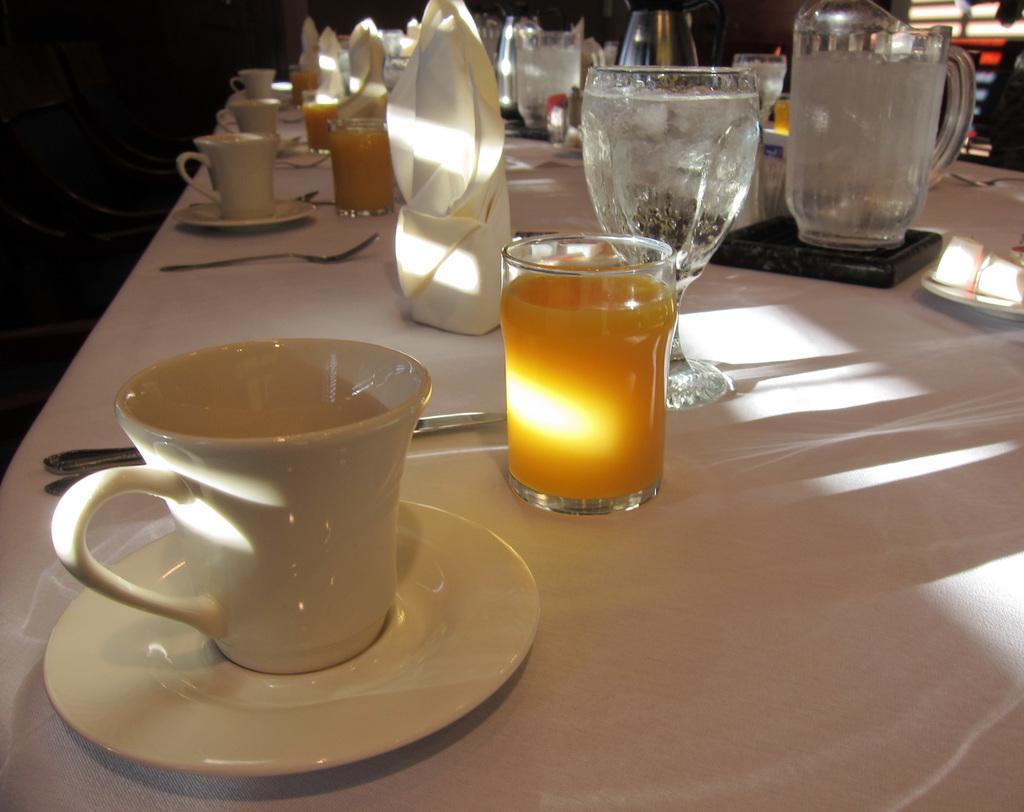Can you describe this image briefly? This is a picture, In the picture there is a table on the table there is a cup and saucer, and this is a glass with juice and this is a spoon on the table there is a jar. 